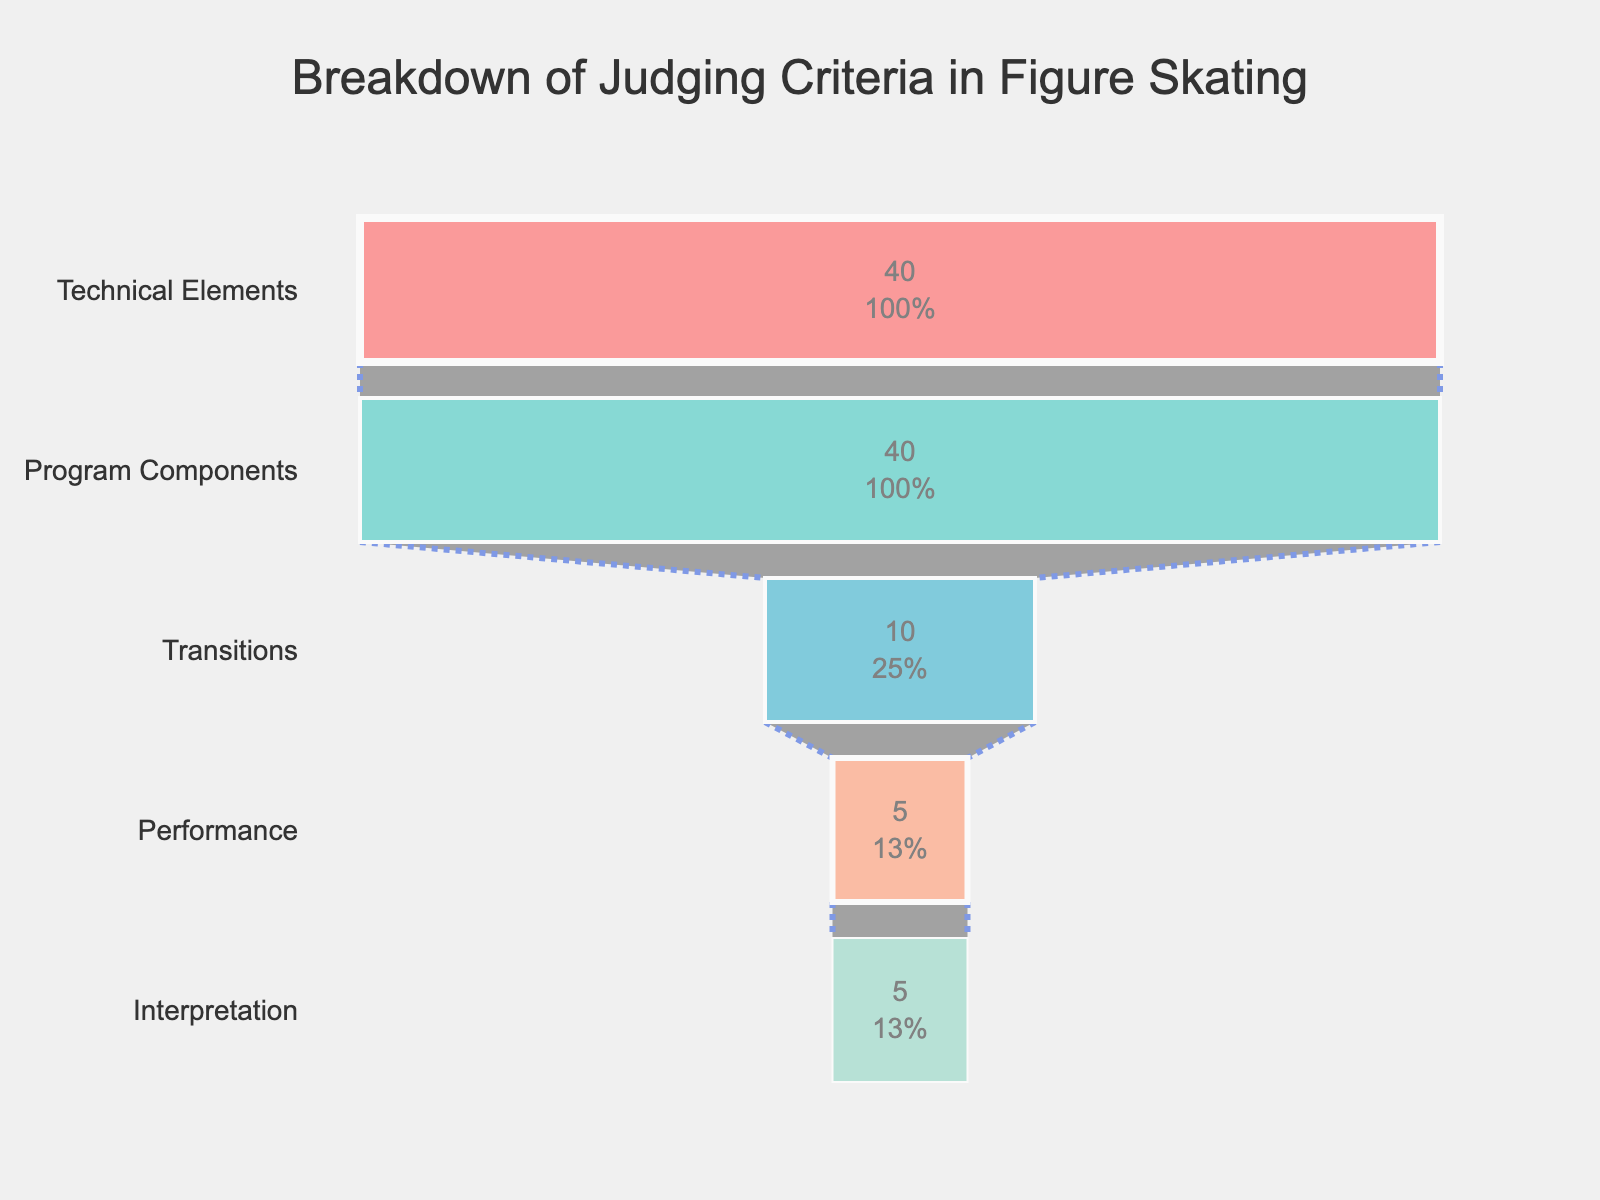What's the title of the chart? The title of the chart is located at the top and is a large, clear text.
Answer: Breakdown of Judging Criteria in Figure Skating What's the category with the highest weight? The category with the highest weight is at the top of the funnel chart and has the largest bar.
Answer: Technical Elements How many categories have been evaluated in the chart? The number of categories can be determined by counting the distinct bars in the funnel chart.
Answer: 5 What is the combined weight of the categories other than Technical Elements? Subtract the weight of Technical Elements from the total. (100 - 40 = 60)
Answer: 60 Which categories have an equal weight? By comparing the lengths of the bars of each category, we find that Technical Elements and Program Components both have bars of equal length.
Answer: Technical Elements and Program Components What percentage of the total weight does the category 'Performance' represent? Divide the weight of 'Performance' by the total weight and multiply by 100. (5 / 100) * 100 = 5%
Answer: 5% How does the weight of 'Transitions' compare to 'Interpretation'? By comparing the lengths of the bars for each category, Transitions have a longer bar compared to Interpretation, reflecting a higher weight.
Answer: Transitions have a higher weight than Interpretation Which two categories combined have a total weight equal to 10%? Find two categories whose weights add up to 10. Both Performance and Interpretation have weights of 5, and together they equal 10.
Answer: Performance and Interpretation If 'Technical Elements' and 'Program Components' are equally important, how much weight do they carry together? Add the weights of both categories. 40 + 40 = 80
Answer: 80 